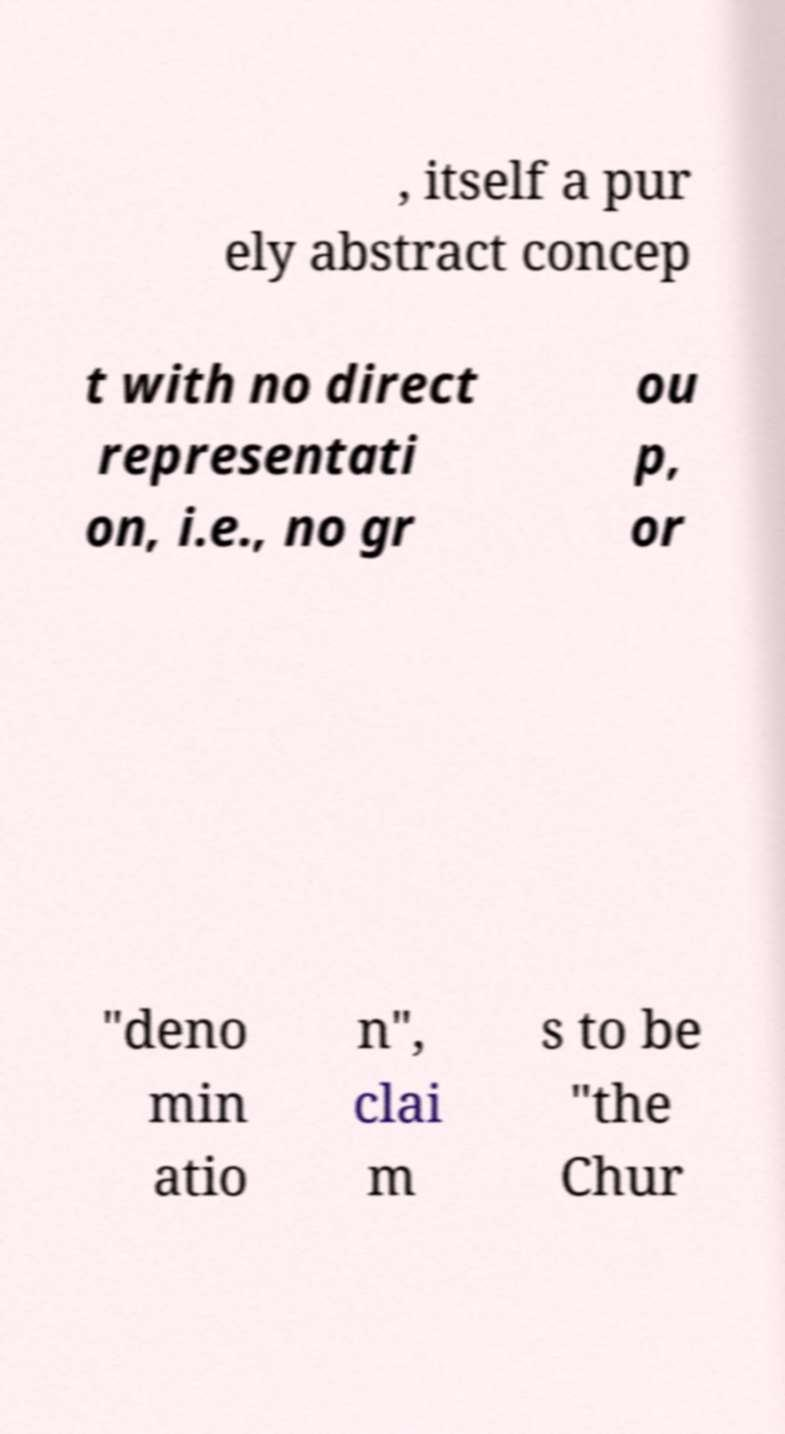I need the written content from this picture converted into text. Can you do that? , itself a pur ely abstract concep t with no direct representati on, i.e., no gr ou p, or "deno min atio n", clai m s to be "the Chur 